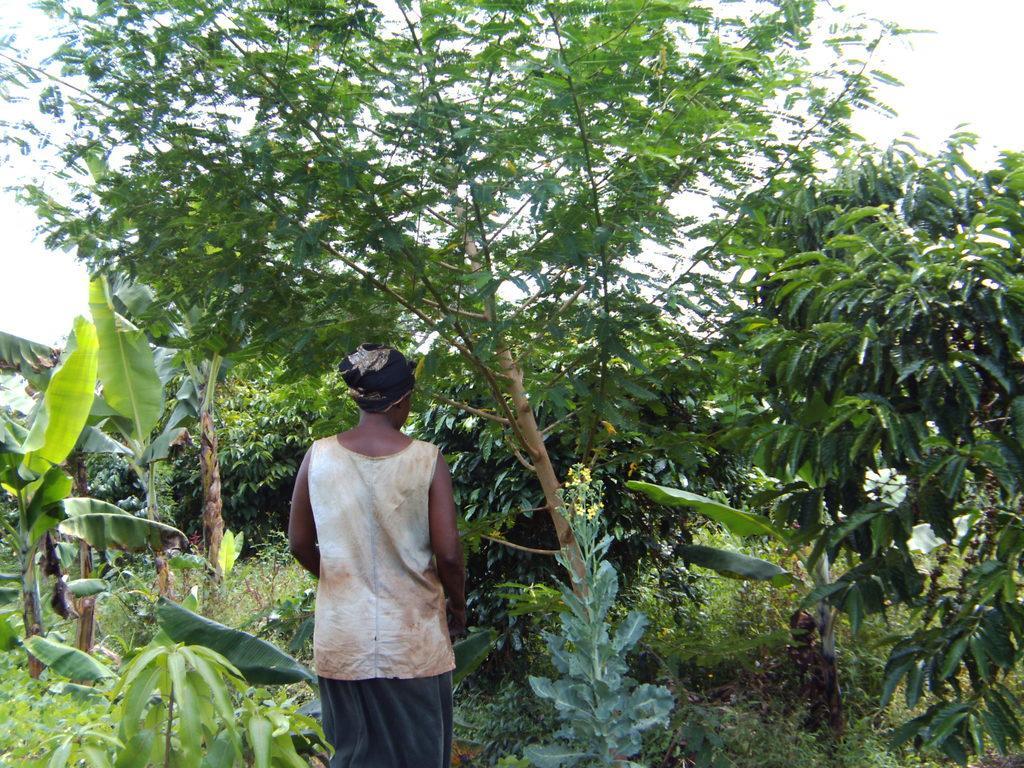Could you give a brief overview of what you see in this image? This image consists of a person. In the background, there are trees and plants. At the top, there is a sky. 